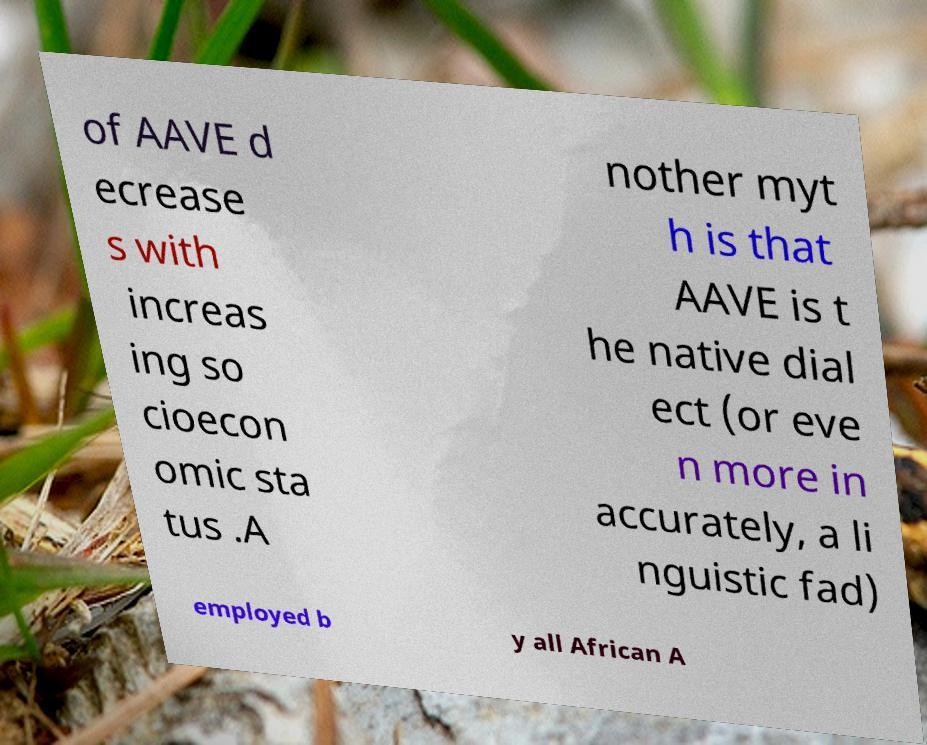Could you extract and type out the text from this image? of AAVE d ecrease s with increas ing so cioecon omic sta tus .A nother myt h is that AAVE is t he native dial ect (or eve n more in accurately, a li nguistic fad) employed b y all African A 